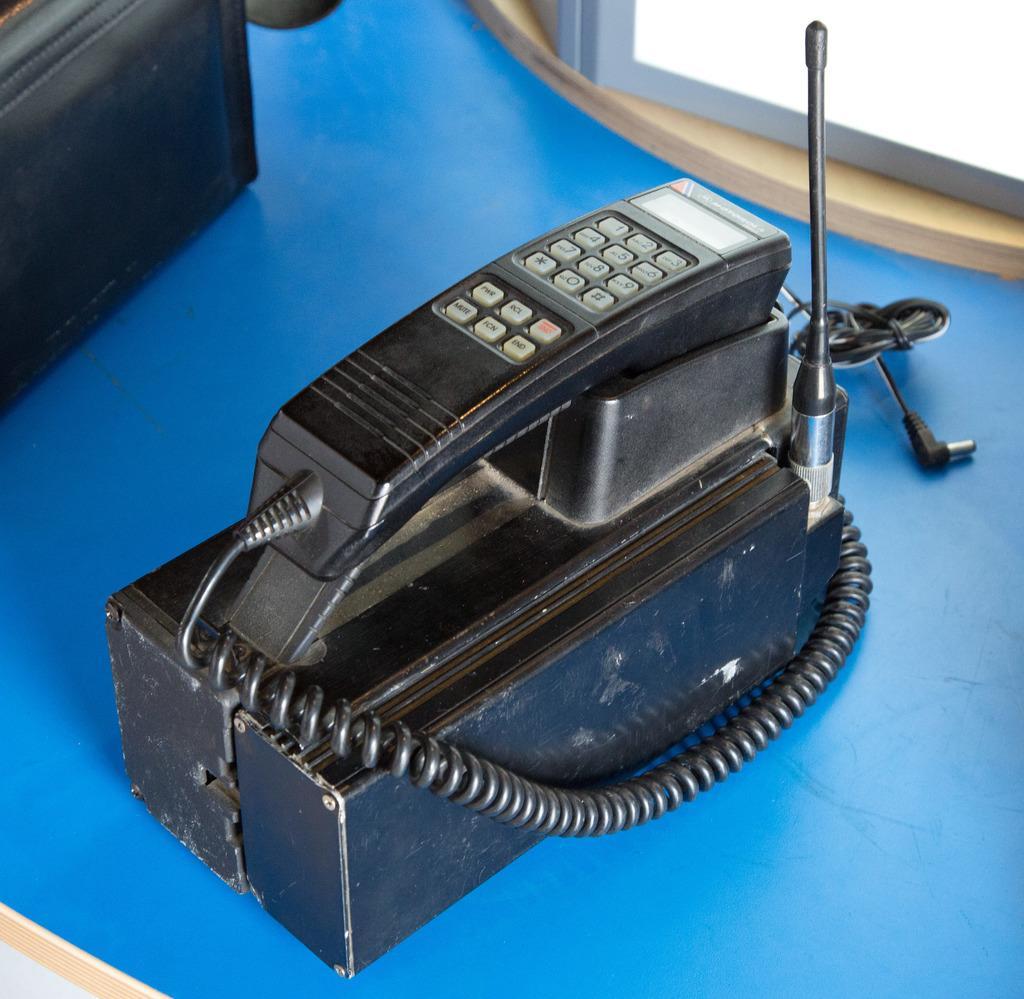In one or two sentences, can you explain what this image depicts? In this image there is a telephone placed on a table. 